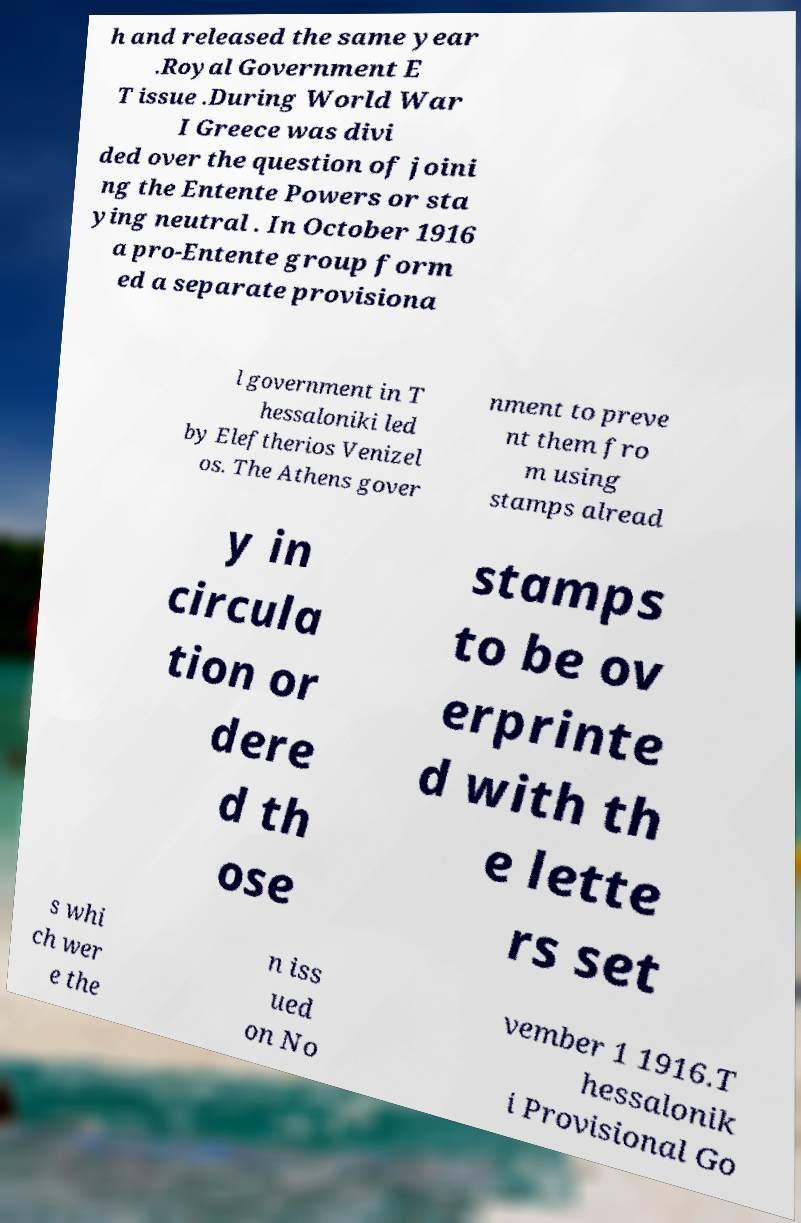Can you read and provide the text displayed in the image?This photo seems to have some interesting text. Can you extract and type it out for me? h and released the same year .Royal Government E T issue .During World War I Greece was divi ded over the question of joini ng the Entente Powers or sta ying neutral . In October 1916 a pro-Entente group form ed a separate provisiona l government in T hessaloniki led by Eleftherios Venizel os. The Athens gover nment to preve nt them fro m using stamps alread y in circula tion or dere d th ose stamps to be ov erprinte d with th e lette rs set s whi ch wer e the n iss ued on No vember 1 1916.T hessalonik i Provisional Go 